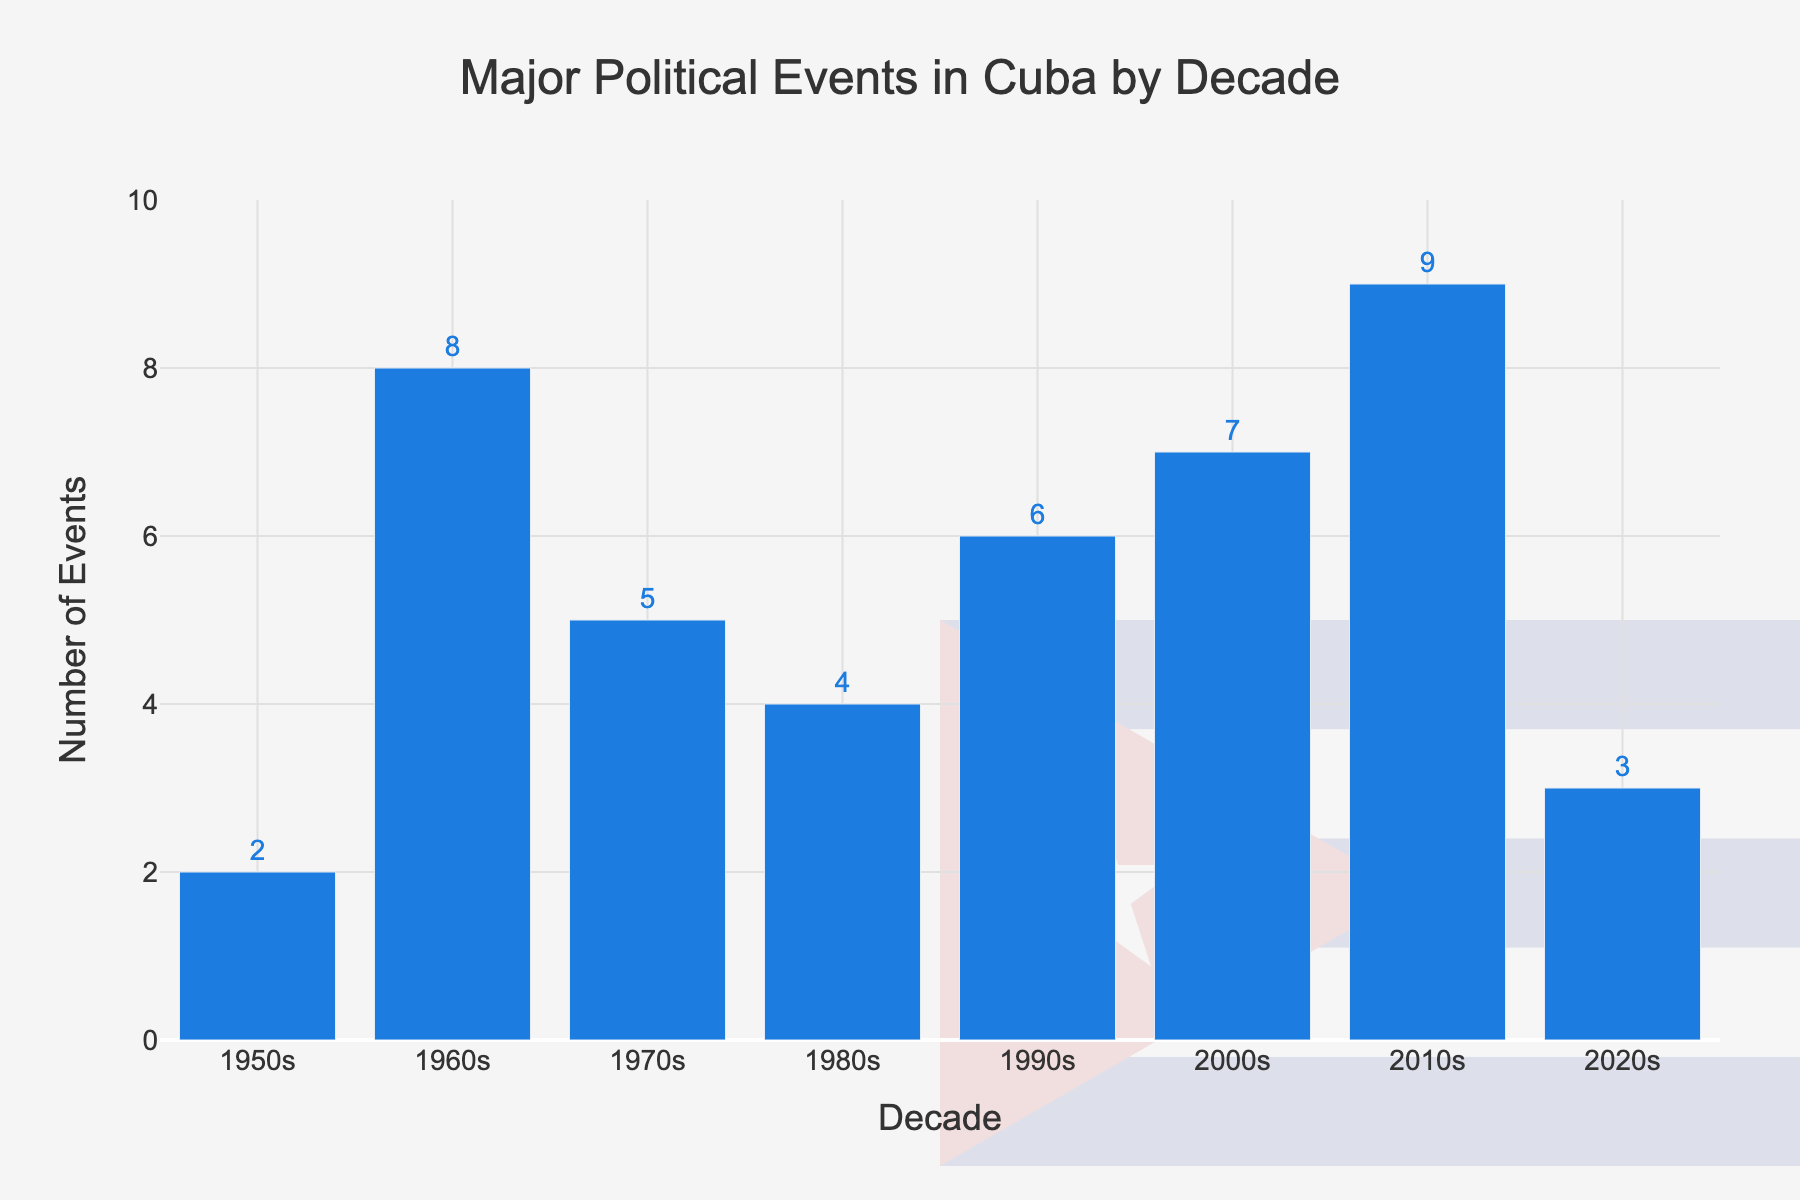Which decade had the highest number of major political events in Cuba? By examining the height of the bars, the 2010s bar is the tallest with 9 events, indicating it had the highest number.
Answer: 2010s How many total major political events occurred from the 1950s to the 2020s? Sum the number of major political events for each decade: 2 + 8 + 5 + 4 + 6 + 7 + 9 + 3 = 44.
Answer: 44 What is the difference in the number of major political events between the 2000s and the 2020s? Subtract the number of events in the 2020s (3) from the number in the 2000s (7): 7 - 3 = 4.
Answer: 4 Which decades had more than 5 major political events? Identify the bars taller than the (5) mark on the y-axis. The decades are the 1960s (8), the 1990s (6), the 2000s (7), and the 2010s (9).
Answer: 1960s, 1990s, 2000s, 2010s What is the average number of major political events per decade? Calculate the total number of events (44) and divide by the number of decades (8): 44 / 8 = 5.5.
Answer: 5.5 Which decades had fewer major political events than the 1980s? The number of events in the 1980s is 4. Decades with fewer events are the 1950s (2) and the 2020s (3).
Answer: 1950s, 2020s Between which decades did the number of major political events increase the most? Compare the height difference of adjacent bars. The increase from the 1950s (2) to the 1960s (8) is the largest: 8 - 2 = 6.
Answer: 1950s to 1960s Which year had the least number of major political events and what might that imply about the political situation in Cuba during that time? The 1950s and 2020s both had the least with 2 and 3 events respectively, implying either less political activity or fewer recorded events.
Answer: 1950s, 2020s What's the sum of the events recorded in the 1970s and the 2000s? Add the number of events for these two decades: 5 (1970s) + 7 (2000s) = 12.
Answer: 12 